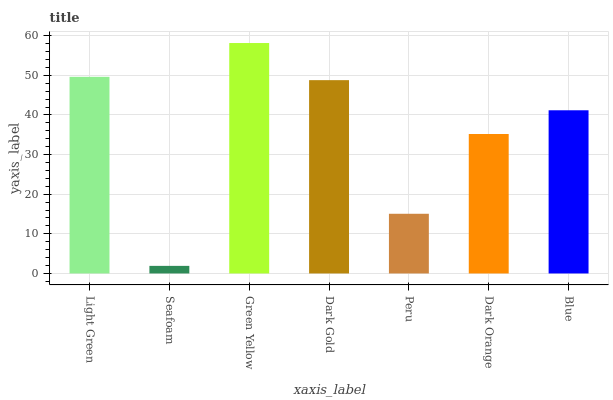Is Green Yellow the minimum?
Answer yes or no. No. Is Seafoam the maximum?
Answer yes or no. No. Is Green Yellow greater than Seafoam?
Answer yes or no. Yes. Is Seafoam less than Green Yellow?
Answer yes or no. Yes. Is Seafoam greater than Green Yellow?
Answer yes or no. No. Is Green Yellow less than Seafoam?
Answer yes or no. No. Is Blue the high median?
Answer yes or no. Yes. Is Blue the low median?
Answer yes or no. Yes. Is Dark Orange the high median?
Answer yes or no. No. Is Dark Orange the low median?
Answer yes or no. No. 